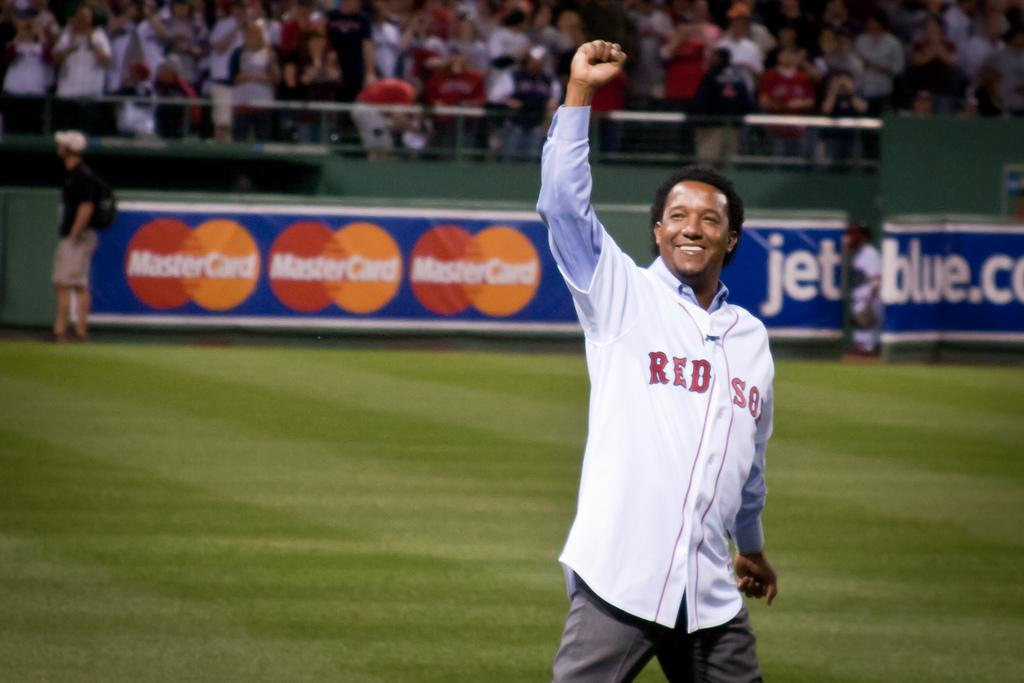<image>
Describe the image concisely. A man in a Red Sox jersey is standing on a baseball fiend with one arm raised in the air. 